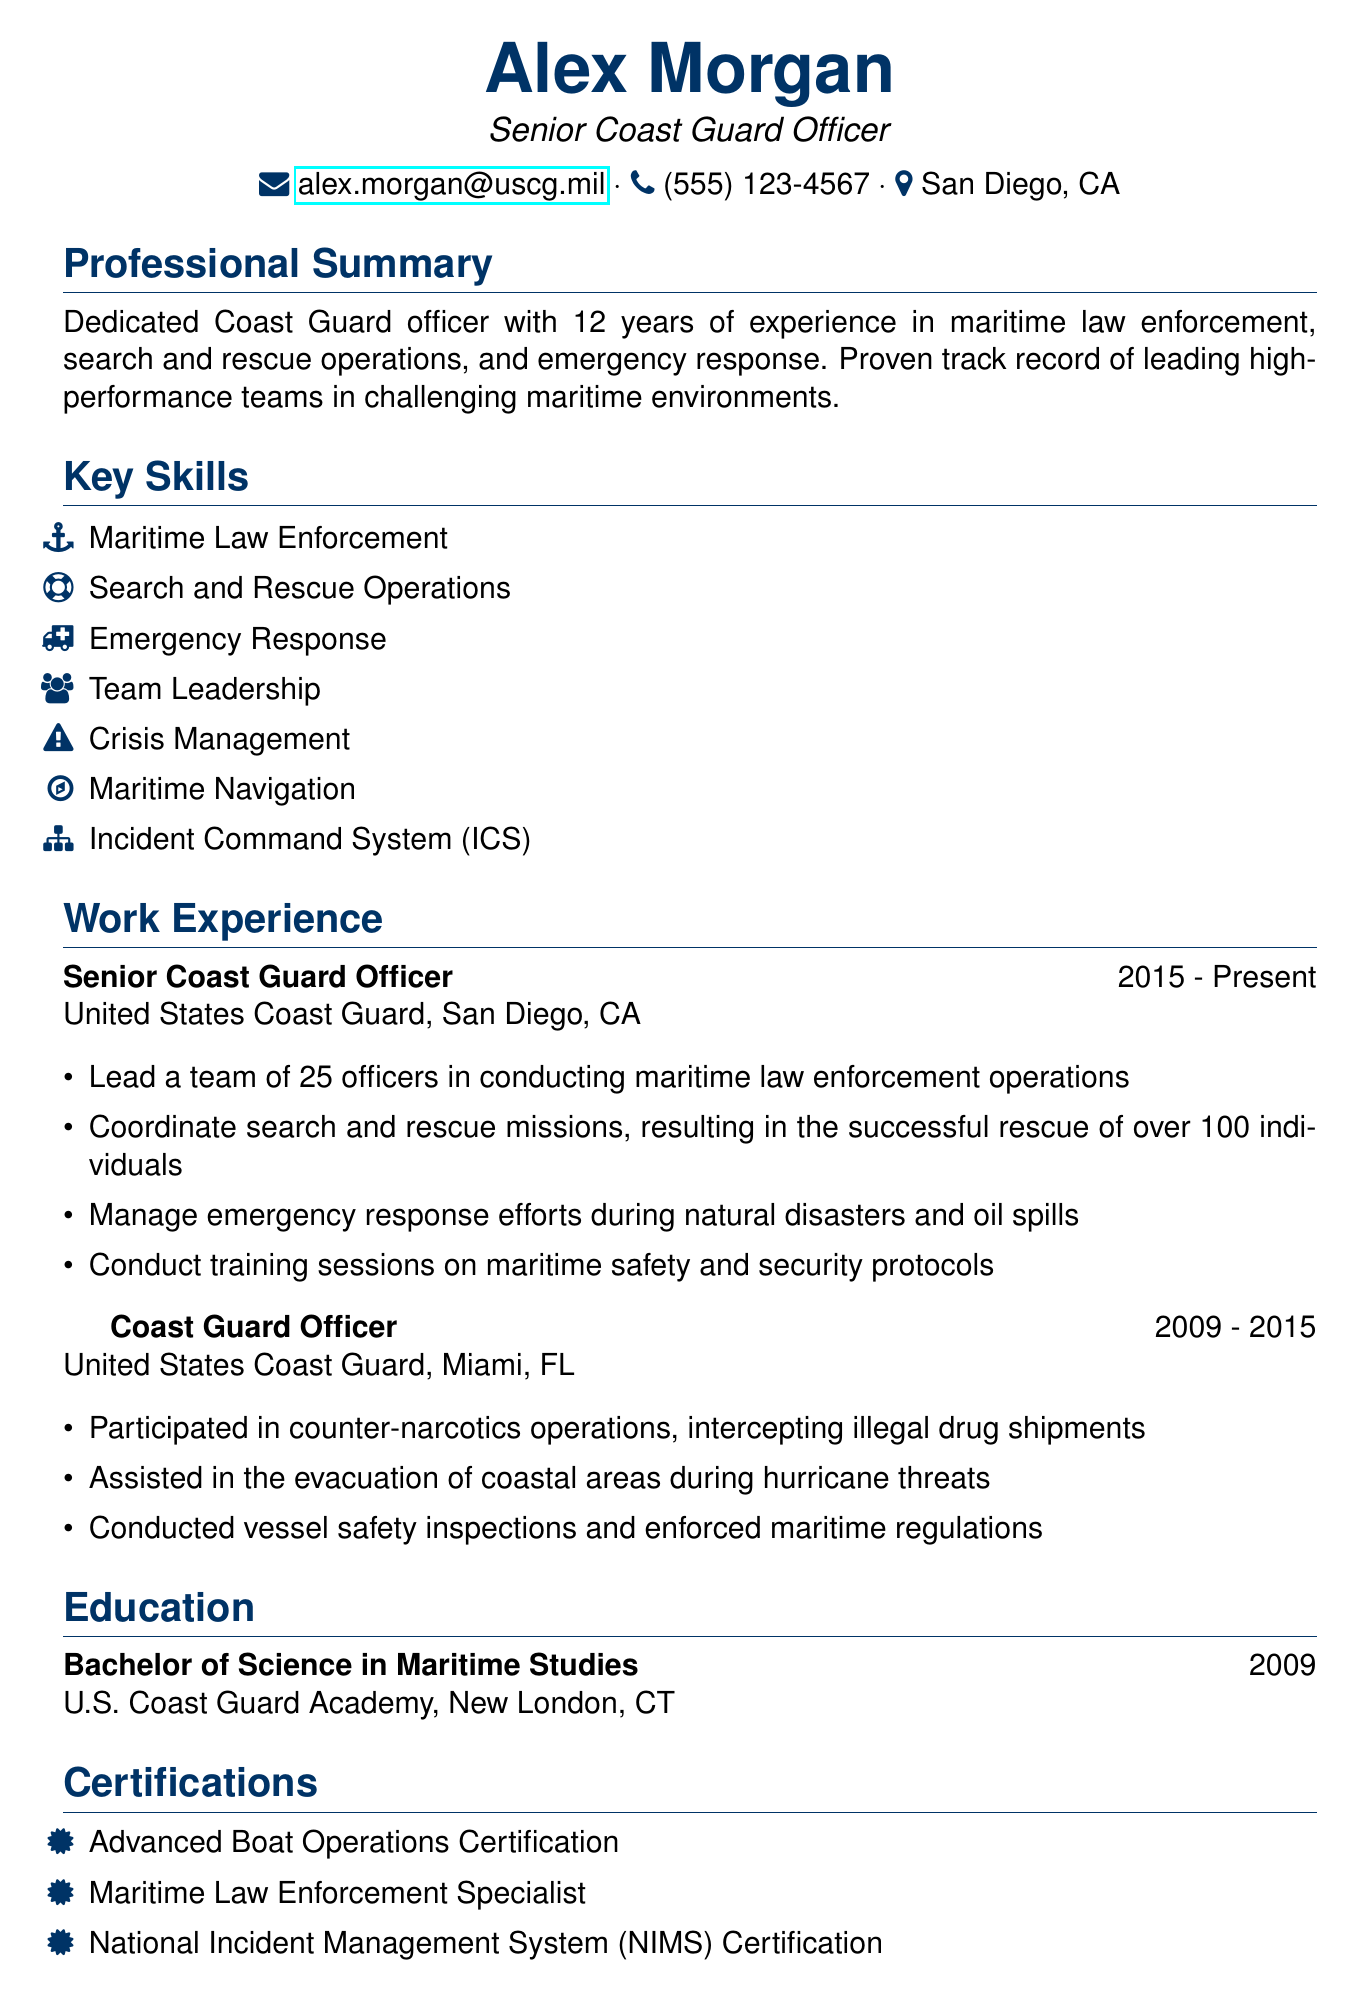what is the name of the coast guard officer? The document contains the personal information section, which lists the name as Alex Morgan.
Answer: Alex Morgan what is the title of the coast guard officer? The title is specified in the personal information section, indicating the officer's position.
Answer: Senior Coast Guard Officer how many years of experience does Alex Morgan have? The professional summary states the number of years of experience the officer has in maritime law enforcement and related fields.
Answer: 12 years which organization does Alex Morgan currently work for? The work experience section indicates the current organization where Alex Morgan is employed.
Answer: United States Coast Guard how many officers does Alex Morgan lead? The work experience section specifies the number of officers under Alex Morgan's leadership in the current role.
Answer: 25 officers what type of degree does Alex Morgan hold? The education section clearly states the degree Alex Morgan obtained from the U.S. Coast Guard Academy.
Answer: Bachelor of Science in Maritime Studies what is one of the certifications held by Alex Morgan? The certifications section lists various certifications; this question asks for just one example.
Answer: Advanced Boat Operations Certification in which city is Alex Morgan currently located? The personal information section provides the current location of Alex Morgan.
Answer: San Diego, CA what is one of the awards received by Alex Morgan? The awards section lists multiple honors Alex Morgan has received for service; the question prompts for one example.
Answer: Coast Guard Commendation Medal 